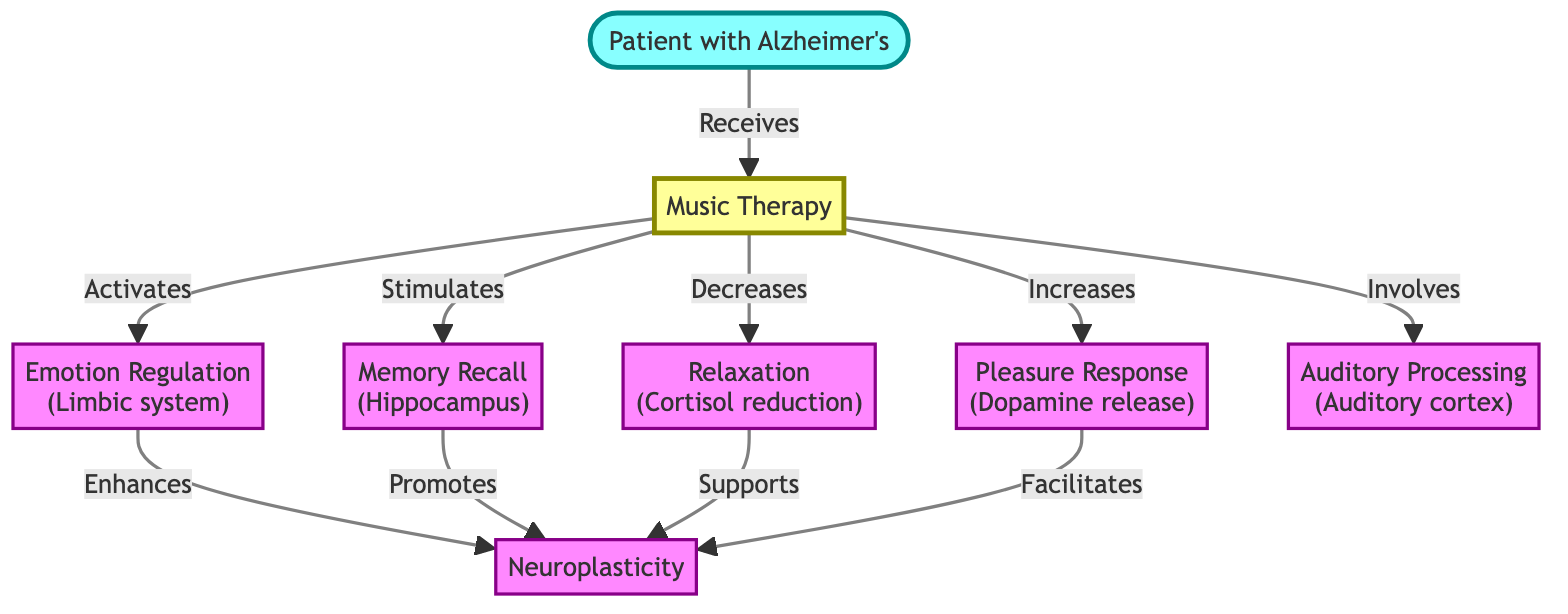What is the primary type of therapy in the diagram? The diagram identifies "Music Therapy" as the key intervention for the "Patient with Alzheimer's". This is represented directly in the content of the node labeled "Music Therapy".
Answer: Music Therapy Which brain region is associated with emotion regulation? The diagram shows that "Emotion Regulation" is linked to the "Limbic system", which is specifically mentioned in its label. This indicates that the limbic system is the brain region responsible for this function.
Answer: Limbic system How many brain regions are activated by music therapy? By analyzing the relevant connections stemming from the "Music Therapy" node, we can identify that music therapy impacts five distinct brain regions namely: Emotion Regulation, Memory Recall, Relaxation, Pleasure Response, and Auditory Processing. Thus, there are five regions in total.
Answer: 5 Which hormone level is decreased as a result of music therapy? According to the diagram, music therapy is explained to result in "Cortisol reduction", specifying cortisol is a hormone whose level decreases. This is clearly stated in the label of the "Relaxation" node connected to music therapy.
Answer: Cortisol What effect does music therapy have on neuroplasticity? The diagram indicates multiple pathways that promote "Neuroplasticity" through various processes. Since both "Emotion Regulation" and "Memory Recall" enhance neuroplasticity, and "Relaxation" and "Pleasure Response" support it, the overall effect of music therapy on neuroplasticity is positive and enhancing.
Answer: Enhances Which brain region is specifically involved in auditory processing? The "Auditory Processing" node explicitly indicates the brain region tasked with processing auditory stimuli. This region is directly linked to music therapy in the diagram, denoting its importance in the therapeutic approach.
Answer: Auditory cortex What triggers pleasure responses according to the diagram? The diagram links "Pleasure Response" directly to "Dopamine release". This indicates that the release of dopamine is the trigger for the pleasurable sensations activated through the music therapy process in patients.
Answer: Dopamine release How does music therapy contribute to memory recall? The diagram illustrates that music therapy "Stimulates" the "Memory Recall" brain region, which is associated with the "Hippocampus". This relationship depicts the contribution of music therapy to enhancing memory functions in Alzheimer's patients.
Answer: Stimulates What is the relationship between emotion regulation and neuroplasticity? The diagram shows that "Emotion Regulation" "Enhances" "Neuroplasticity". This signifies that effective emotion regulation not only occurs but also actively contributes to the capabilities of neuroplasticity in response to music therapy.
Answer: Enhances 